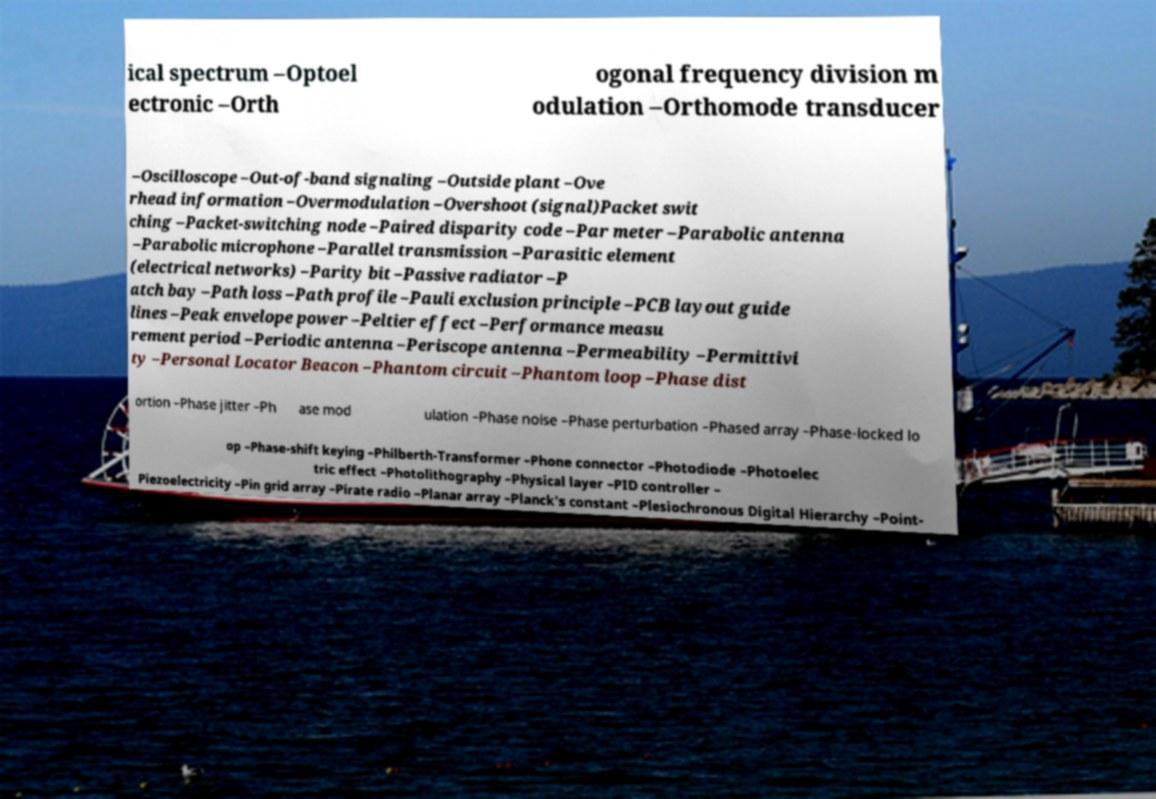Please identify and transcribe the text found in this image. ical spectrum –Optoel ectronic –Orth ogonal frequency division m odulation –Orthomode transducer –Oscilloscope –Out-of-band signaling –Outside plant –Ove rhead information –Overmodulation –Overshoot (signal)Packet swit ching –Packet-switching node –Paired disparity code –Par meter –Parabolic antenna –Parabolic microphone –Parallel transmission –Parasitic element (electrical networks) –Parity bit –Passive radiator –P atch bay –Path loss –Path profile –Pauli exclusion principle –PCB layout guide lines –Peak envelope power –Peltier effect –Performance measu rement period –Periodic antenna –Periscope antenna –Permeability –Permittivi ty –Personal Locator Beacon –Phantom circuit –Phantom loop –Phase dist ortion –Phase jitter –Ph ase mod ulation –Phase noise –Phase perturbation –Phased array –Phase-locked lo op –Phase-shift keying –Philberth-Transformer –Phone connector –Photodiode –Photoelec tric effect –Photolithography –Physical layer –PID controller – Piezoelectricity –Pin grid array –Pirate radio –Planar array –Planck's constant –Plesiochronous Digital Hierarchy –Point- 